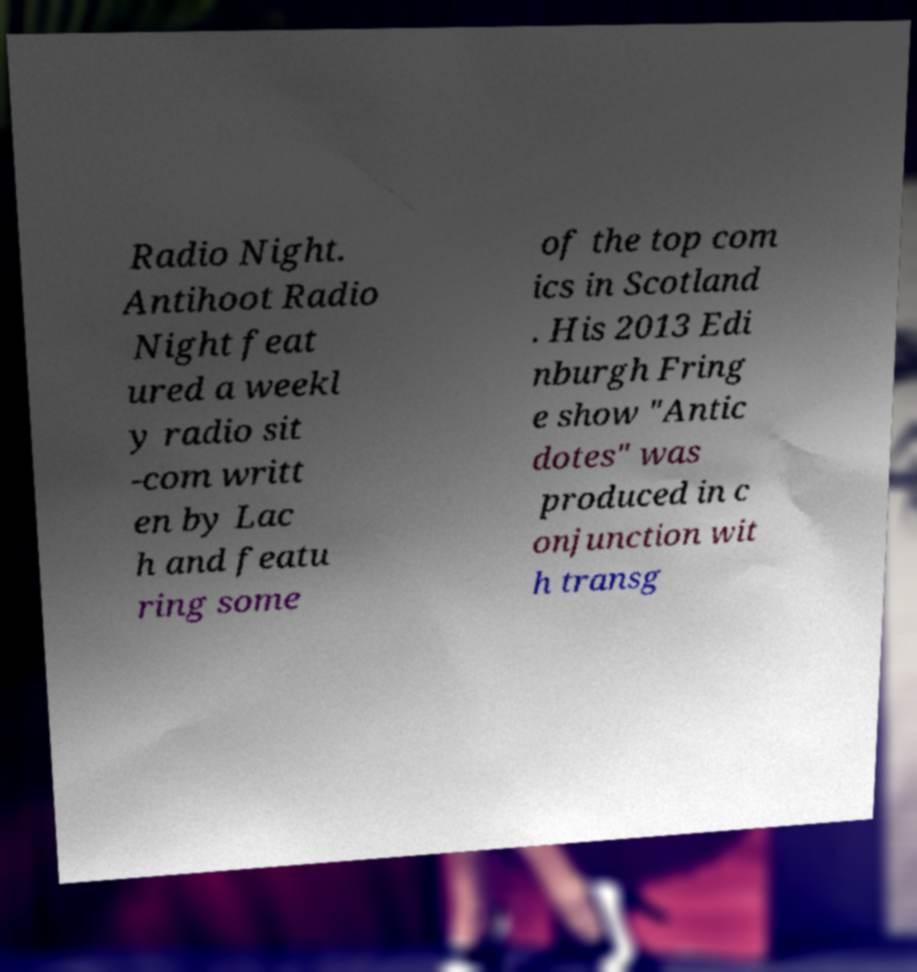Please read and relay the text visible in this image. What does it say? Radio Night. Antihoot Radio Night feat ured a weekl y radio sit -com writt en by Lac h and featu ring some of the top com ics in Scotland . His 2013 Edi nburgh Fring e show "Antic dotes" was produced in c onjunction wit h transg 